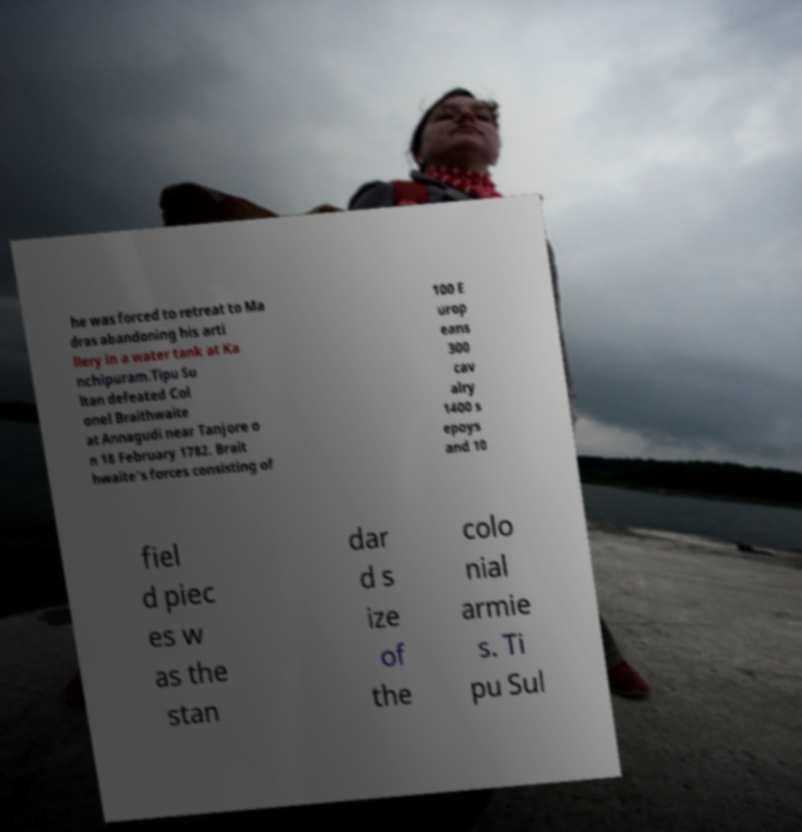Can you read and provide the text displayed in the image?This photo seems to have some interesting text. Can you extract and type it out for me? he was forced to retreat to Ma dras abandoning his arti llery in a water tank at Ka nchipuram.Tipu Su ltan defeated Col onel Braithwaite at Annagudi near Tanjore o n 18 February 1782. Brait hwaite's forces consisting of 100 E urop eans 300 cav alry 1400 s epoys and 10 fiel d piec es w as the stan dar d s ize of the colo nial armie s. Ti pu Sul 